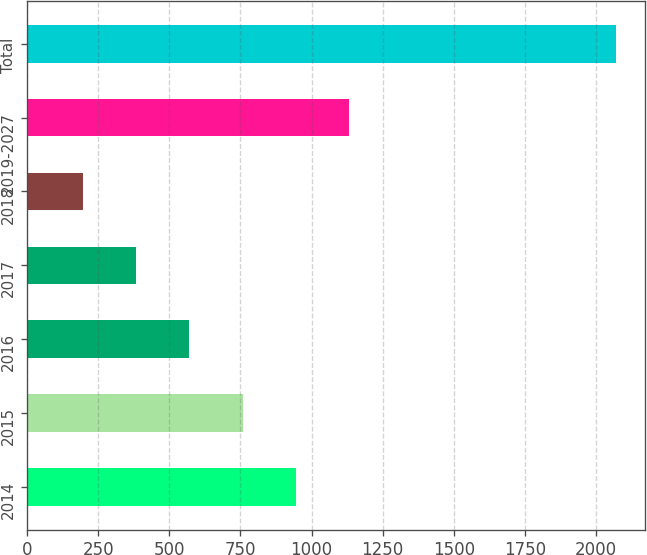Convert chart to OTSL. <chart><loc_0><loc_0><loc_500><loc_500><bar_chart><fcel>2014<fcel>2015<fcel>2016<fcel>2017<fcel>2018<fcel>2019-2027<fcel>Total<nl><fcel>945.2<fcel>757.9<fcel>570.6<fcel>383.3<fcel>196<fcel>1132.5<fcel>2069<nl></chart> 